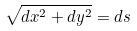Convert formula to latex. <formula><loc_0><loc_0><loc_500><loc_500>\sqrt { d x ^ { 2 } + d y ^ { 2 } } = d s</formula> 